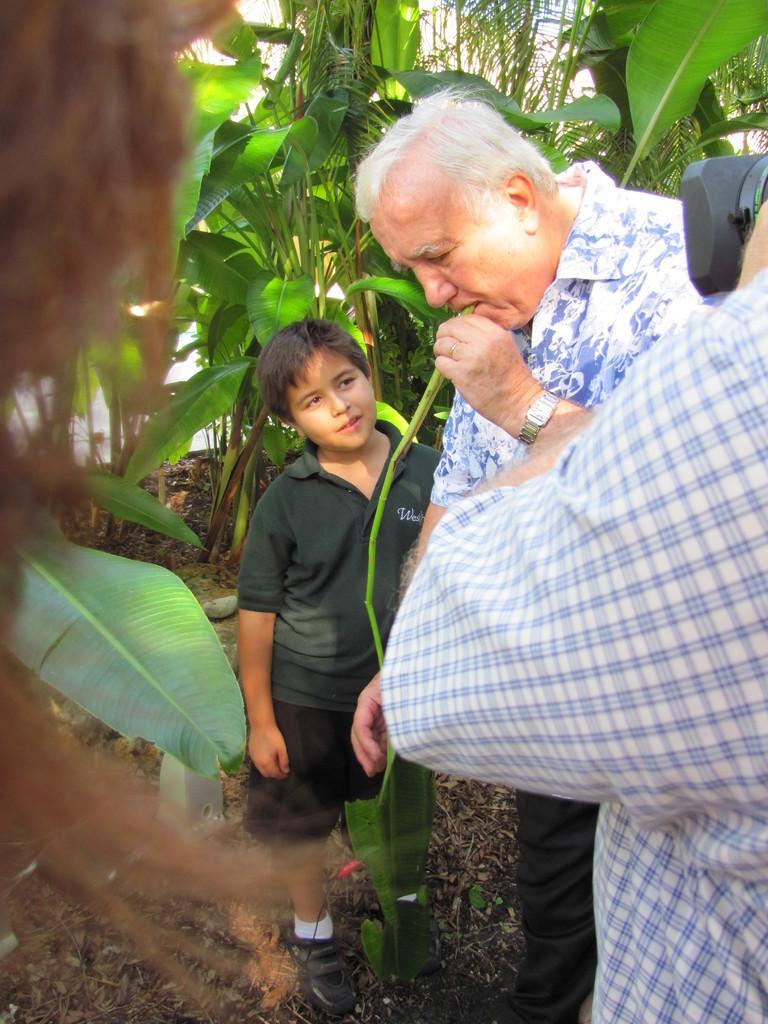Can you describe this image briefly? In this image we can see a old man is holding a green color item in his hand and beside him a boy is standing on the ground. On the right side we can see a person and a camera. In the background there are plants and trees on the ground and we can see the sky. On the left side there is an object. 